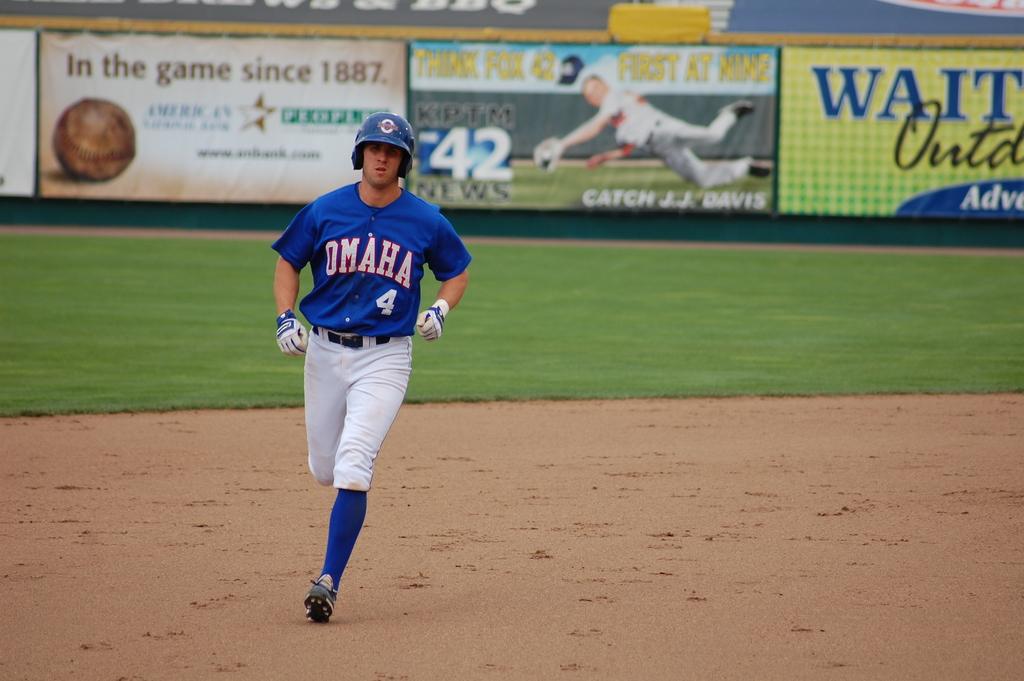What team uniform is the player wearing?
Provide a short and direct response. Omaha. What number is the player?
Your response must be concise. 4. 